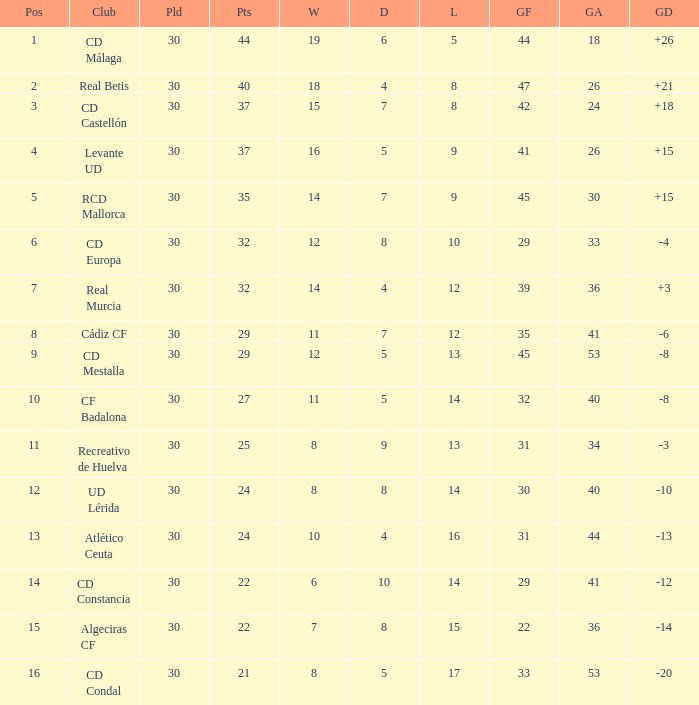What is the number of draws when played is smaller than 30? 0.0. 